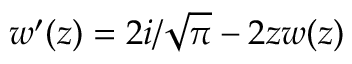<formula> <loc_0><loc_0><loc_500><loc_500>w ^ { \prime } ( z ) = 2 i / \sqrt { \pi } - 2 z w ( z )</formula> 